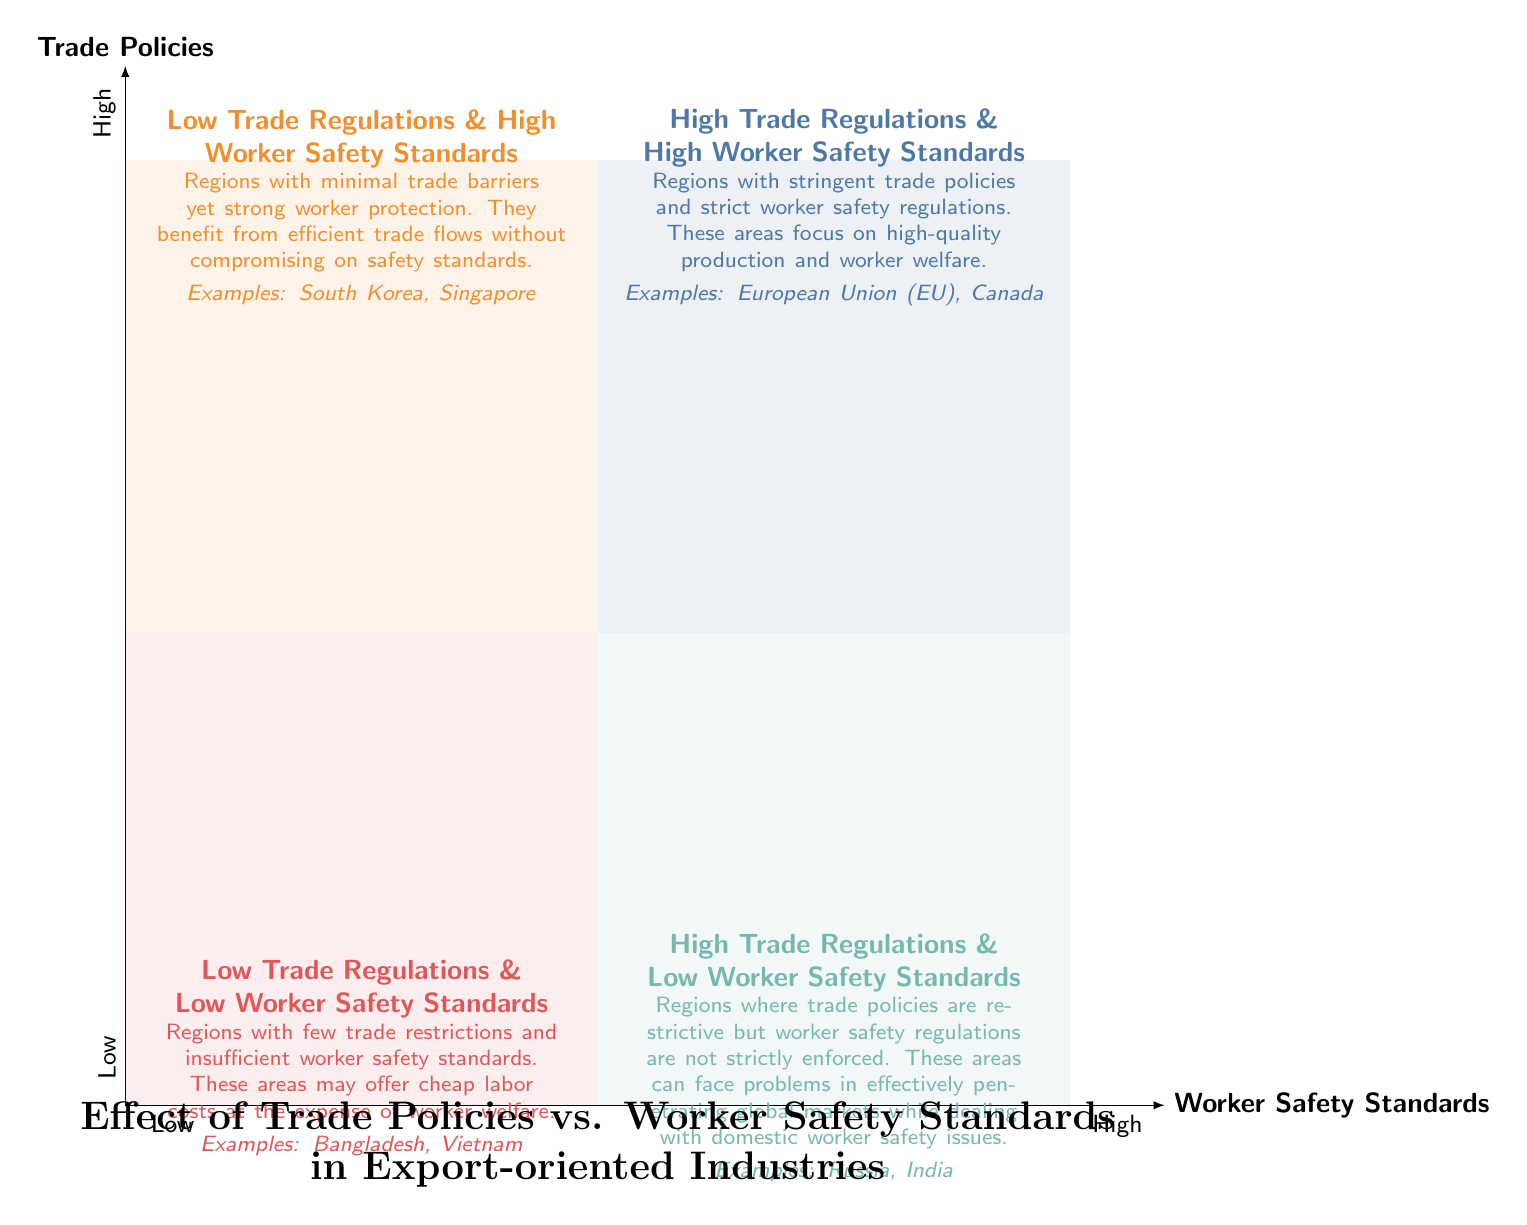What are the examples listed in the quadrant for High Trade Regulations and High Worker Safety Standards? The quadrant has examples highlighting regions with high trade regulations and worker safety standards. According to the diagram, the examples in this quadrant are the European Union (EU) and Canada.
Answer: European Union (EU), Canada Which quadrant contains Bangladesh as an example? Bangladesh is mentioned under the quadrant that describes regions with low trade regulations and low worker safety standards. This is seen by locating Bangladesh in the quadrant labeled as such.
Answer: Low Trade Regulations & Low Worker Safety Standards What is the primary characteristic of regions in the Low Trade Regulations & High Worker Safety Standards quadrant? This quadrant represents regions that have minimal trade barriers while maintaining strong protection for workers. By evaluating the quadrant description, we see that it focuses on efficient trade without compromising safety.
Answer: Minimal trade barriers yet strong worker protection How many examples are provided for each quadrant? By examining each quadrant's examples, we see that each quadrant mentions two examples. This indicates uniformity within the provided examples throughout the quadrants.
Answer: Two Which two countries are in the High Trade Regulations & Low Worker Safety Standards quadrant? The countries Russia and India are stated as examples in the quadrant with high trade regulations but low worker safety standards. We look at the examples listed in that specific quadrant to confirm the answer.
Answer: Russia, India How does the level of worker safety standards compare between the Low Trade Regulations & Low Worker Safety Standards quadrant and the High Trade Regulations & High Worker Safety Standards quadrant? The Low Trade Regulations & Low Worker Safety Standards quadrant has low worker safety standards, while the High Trade Regulations & High Worker Safety Standards quadrant has high worker safety standards. The descriptions in each quadrant provide this information, showing the contrast in safety standards.
Answer: Low vs. High What is the overall theme of the diagram? The overall theme of the diagram revolves around the relationship between trade policies and worker safety standards in export-oriented industries, as outlined in the title and descriptions of the quadrants. This indicates how these two factors interact and affect different regions.
Answer: Effect of Trade Policies vs. Worker Safety Standards Which quadrant represents regions with both low trade barriers and insufficient worker safety standards? This scenario is described in the quadrant labeled Low Trade Regulations & Low Worker Safety Standards. The quadrant's description contains the necessary details about the characteristics of these regions.
Answer: Low Trade Regulations & Low Worker Safety Standards 